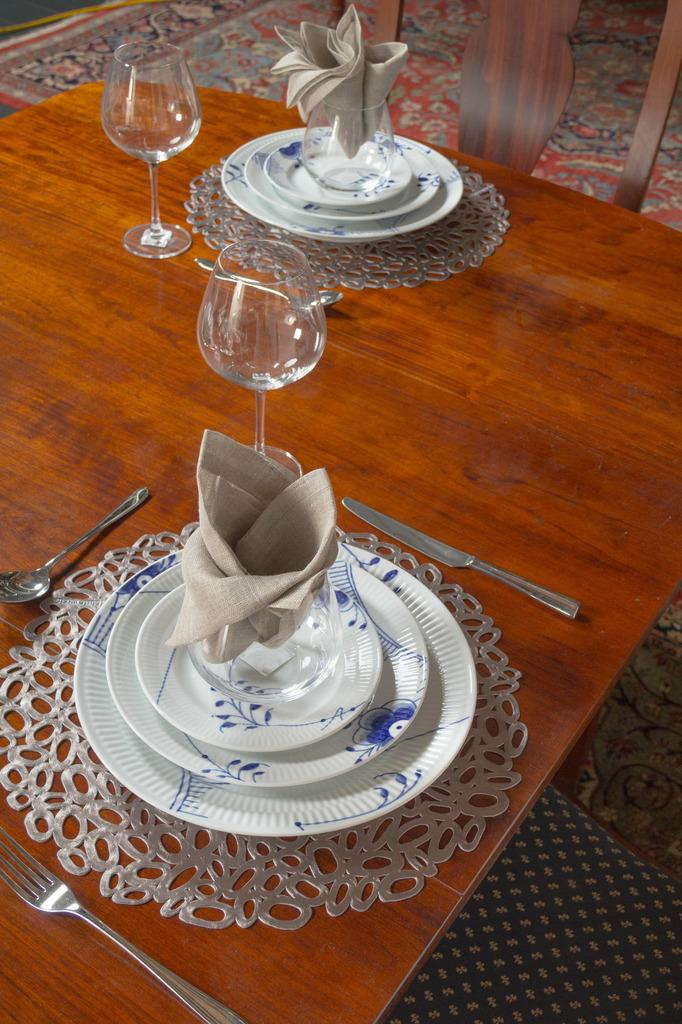What type of furniture is present in the image? There is a chair and a table in the image. What is placed on the table? There are plates, two glasses, a spoon, a fork, and a knife on the table. Are there any utensils visible in the image? Yes, there is a spoon, a fork, and a knife on the table. Can you describe the clothes visible in the image? The provided facts do not mention any specific details about the clothes, so we cannot describe them. What type of linen is draped over the top of the chair in the image? There is no linen draped over the top of the chair in the image. How does the ice interact with the utensils on the table in the image? There is no ice present in the image, so it cannot interact with the utensils. 